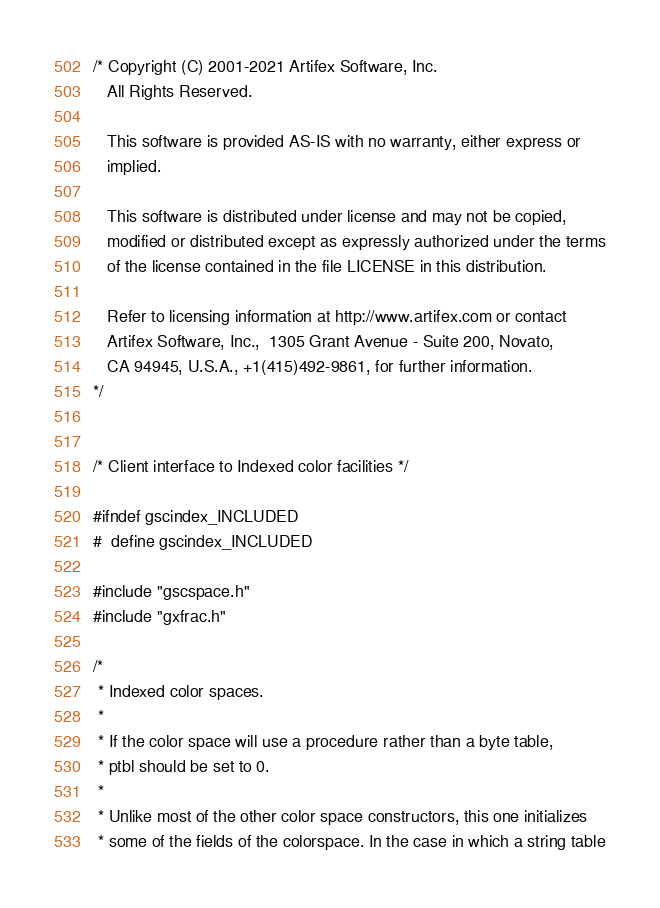Convert code to text. <code><loc_0><loc_0><loc_500><loc_500><_C_>/* Copyright (C) 2001-2021 Artifex Software, Inc.
   All Rights Reserved.

   This software is provided AS-IS with no warranty, either express or
   implied.

   This software is distributed under license and may not be copied,
   modified or distributed except as expressly authorized under the terms
   of the license contained in the file LICENSE in this distribution.

   Refer to licensing information at http://www.artifex.com or contact
   Artifex Software, Inc.,  1305 Grant Avenue - Suite 200, Novato,
   CA 94945, U.S.A., +1(415)492-9861, for further information.
*/


/* Client interface to Indexed color facilities */

#ifndef gscindex_INCLUDED
#  define gscindex_INCLUDED

#include "gscspace.h"
#include "gxfrac.h"

/*
 * Indexed color spaces.
 *
 * If the color space will use a procedure rather than a byte table,
 * ptbl should be set to 0.
 *
 * Unlike most of the other color space constructors, this one initializes
 * some of the fields of the colorspace. In the case in which a string table</code> 